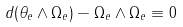<formula> <loc_0><loc_0><loc_500><loc_500>d ( \theta _ { e } \wedge \Omega _ { e } ) - \Omega _ { e } \wedge \Omega _ { e } \equiv 0</formula> 